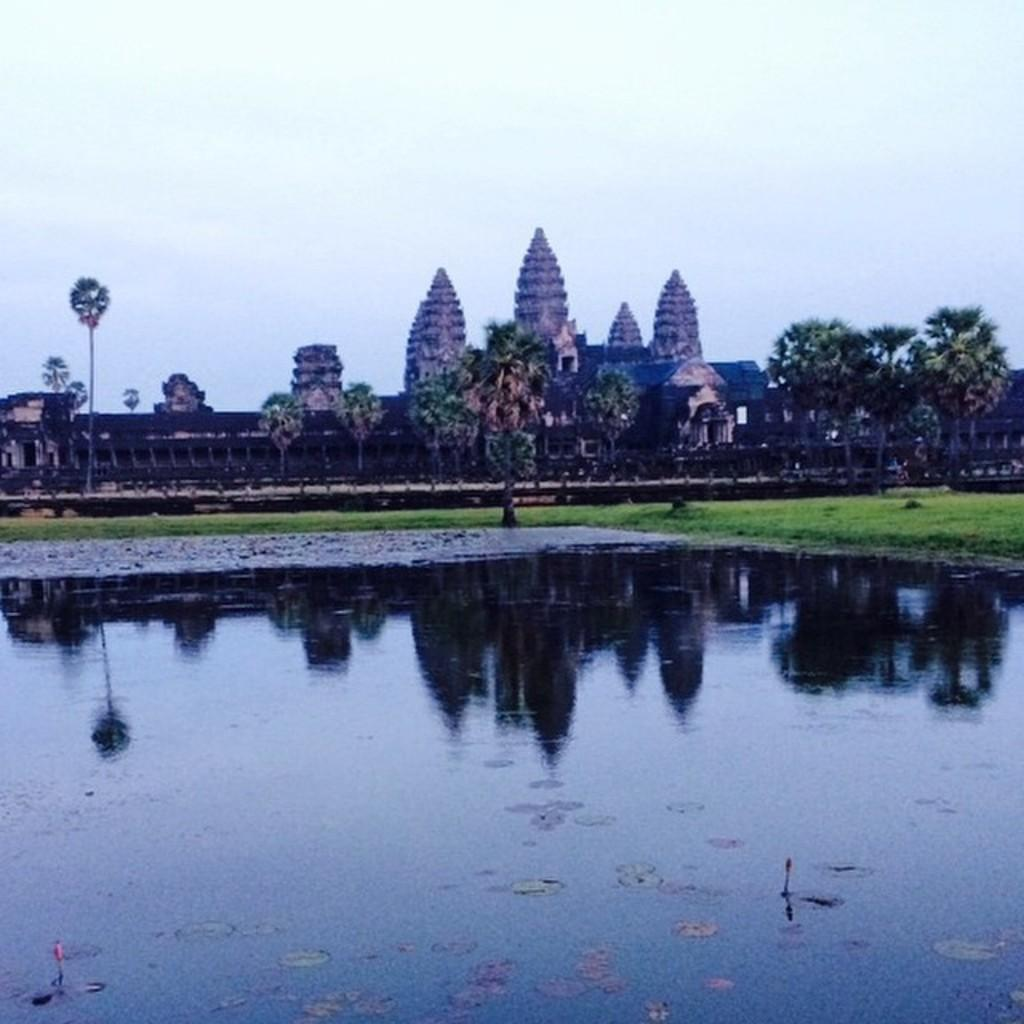What is the primary element visible in the image? There is water in the image. What can be seen in the background of the image? There are trees, grass, and buildings in the background of the image. How many lizards can be seen swimming in the water in the image? There are no lizards visible in the image; it only features water, trees, grass, and buildings in the background. 